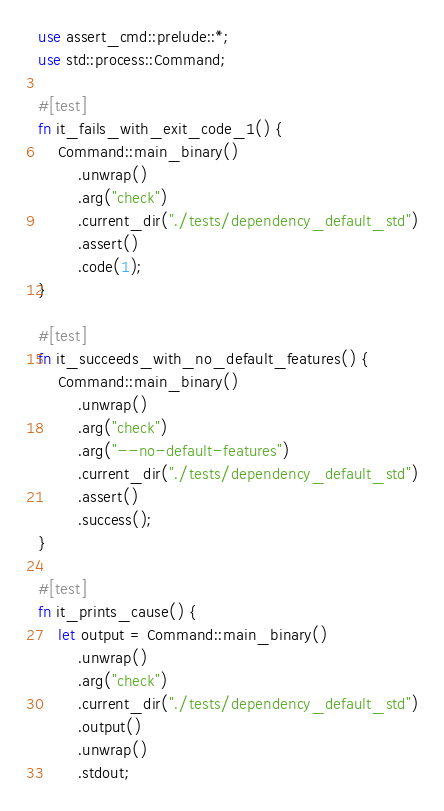<code> <loc_0><loc_0><loc_500><loc_500><_Rust_>
use assert_cmd::prelude::*;
use std::process::Command;

#[test]
fn it_fails_with_exit_code_1() {
    Command::main_binary()
        .unwrap()
        .arg("check")
        .current_dir("./tests/dependency_default_std")
        .assert()
        .code(1);
}

#[test]
fn it_succeeds_with_no_default_features() {
    Command::main_binary()
        .unwrap()
        .arg("check")
        .arg("--no-default-features")
        .current_dir("./tests/dependency_default_std")
        .assert()
        .success();
}

#[test]
fn it_prints_cause() {
    let output = Command::main_binary()
        .unwrap()
        .arg("check")
        .current_dir("./tests/dependency_default_std")
        .output()
        .unwrap()
        .stdout;</code> 